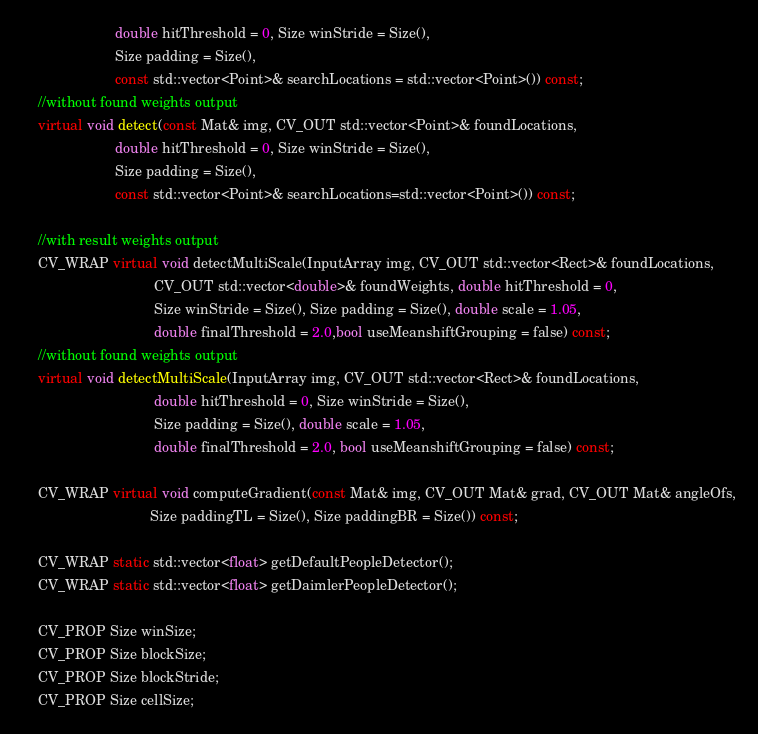<code> <loc_0><loc_0><loc_500><loc_500><_C++_>                        double hitThreshold = 0, Size winStride = Size(),
                        Size padding = Size(),
                        const std::vector<Point>& searchLocations = std::vector<Point>()) const;
    //without found weights output
    virtual void detect(const Mat& img, CV_OUT std::vector<Point>& foundLocations,
                        double hitThreshold = 0, Size winStride = Size(),
                        Size padding = Size(),
                        const std::vector<Point>& searchLocations=std::vector<Point>()) const;

    //with result weights output
    CV_WRAP virtual void detectMultiScale(InputArray img, CV_OUT std::vector<Rect>& foundLocations,
                                  CV_OUT std::vector<double>& foundWeights, double hitThreshold = 0,
                                  Size winStride = Size(), Size padding = Size(), double scale = 1.05,
                                  double finalThreshold = 2.0,bool useMeanshiftGrouping = false) const;
    //without found weights output
    virtual void detectMultiScale(InputArray img, CV_OUT std::vector<Rect>& foundLocations,
                                  double hitThreshold = 0, Size winStride = Size(),
                                  Size padding = Size(), double scale = 1.05,
                                  double finalThreshold = 2.0, bool useMeanshiftGrouping = false) const;

    CV_WRAP virtual void computeGradient(const Mat& img, CV_OUT Mat& grad, CV_OUT Mat& angleOfs,
                                 Size paddingTL = Size(), Size paddingBR = Size()) const;

    CV_WRAP static std::vector<float> getDefaultPeopleDetector();
    CV_WRAP static std::vector<float> getDaimlerPeopleDetector();

    CV_PROP Size winSize;
    CV_PROP Size blockSize;
    CV_PROP Size blockStride;
    CV_PROP Size cellSize;</code> 